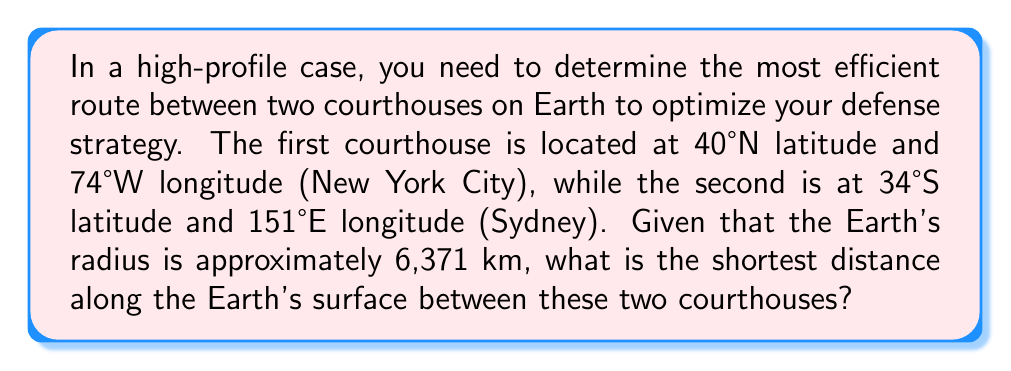Show me your answer to this math problem. To solve this problem, we need to use the great circle distance formula, which gives the shortest path between two points on a sphere. This is crucial for optimizing courtroom strategy by minimizing travel time.

Step 1: Convert the latitudes and longitudes to radians.
Let $\phi_1, \lambda_1$ be the latitude and longitude of New York, and $\phi_2, \lambda_2$ be those of Sydney.

$\phi_1 = 40° \cdot \frac{\pi}{180} = 0.6981$ radians
$\lambda_1 = -74° \cdot \frac{\pi}{180} = -1.2915$ radians
$\phi_2 = -34° \cdot \frac{\pi}{180} = -0.5934$ radians
$\lambda_2 = 151° \cdot \frac{\pi}{180} = 2.6354$ radians

Step 2: Calculate the central angle $\Delta \sigma$ using the great circle distance formula:

$$\Delta \sigma = \arccos(\sin\phi_1 \sin\phi_2 + \cos\phi_1 \cos\phi_2 \cos(\lambda_2 - \lambda_1))$$

Substituting the values:

$$\Delta \sigma = \arccos(\sin(0.6981) \sin(-0.5934) + \cos(0.6981) \cos(-0.5934) \cos(2.6354 - (-1.2915)))$$

$$\Delta \sigma = \arccos(-0.0823 + 0.7660 \cdot 0.8261 \cdot (-0.9397))$$

$$\Delta \sigma = \arccos(-0.5912) = 2.1843 \text{ radians}$$

Step 3: Calculate the great circle distance $d$ by multiplying the central angle by the Earth's radius:

$$d = R \cdot \Delta \sigma$$
$$d = 6371 \text{ km} \cdot 2.1843$$
$$d = 13,915.8 \text{ km}$$

This is the shortest distance along the Earth's surface between the two courthouses.
Answer: 13,915.8 km 